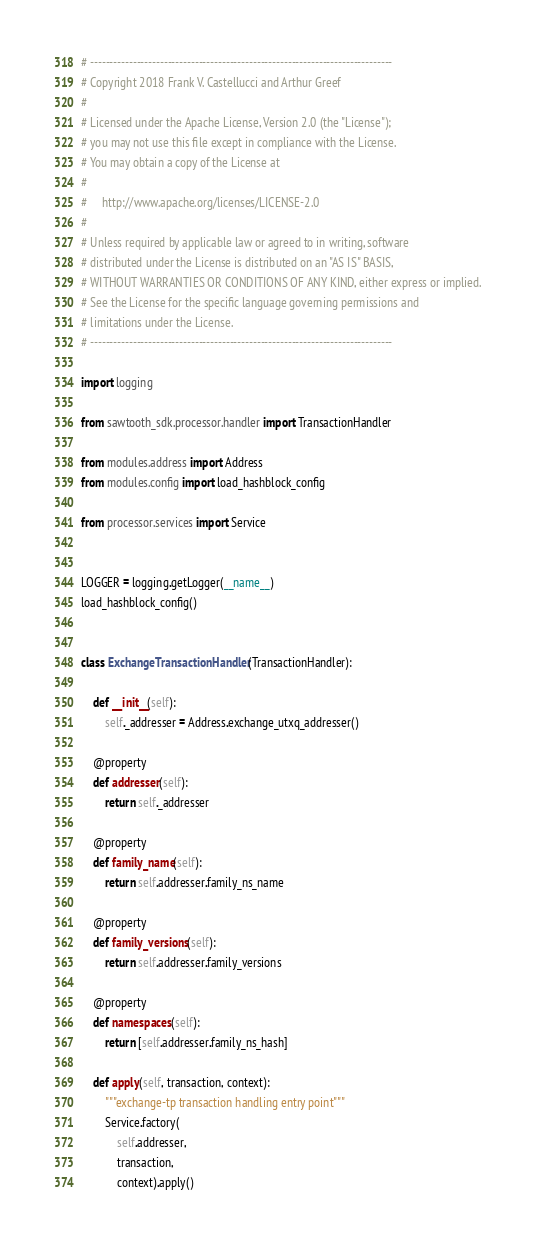<code> <loc_0><loc_0><loc_500><loc_500><_Python_># ------------------------------------------------------------------------------
# Copyright 2018 Frank V. Castellucci and Arthur Greef
#
# Licensed under the Apache License, Version 2.0 (the "License");
# you may not use this file except in compliance with the License.
# You may obtain a copy of the License at
#
#     http://www.apache.org/licenses/LICENSE-2.0
#
# Unless required by applicable law or agreed to in writing, software
# distributed under the License is distributed on an "AS IS" BASIS,
# WITHOUT WARRANTIES OR CONDITIONS OF ANY KIND, either express or implied.
# See the License for the specific language governing permissions and
# limitations under the License.
# ------------------------------------------------------------------------------

import logging

from sawtooth_sdk.processor.handler import TransactionHandler

from modules.address import Address
from modules.config import load_hashblock_config

from processor.services import Service


LOGGER = logging.getLogger(__name__)
load_hashblock_config()


class ExchangeTransactionHandler(TransactionHandler):

    def __init__(self):
        self._addresser = Address.exchange_utxq_addresser()

    @property
    def addresser(self):
        return self._addresser

    @property
    def family_name(self):
        return self.addresser.family_ns_name

    @property
    def family_versions(self):
        return self.addresser.family_versions

    @property
    def namespaces(self):
        return [self.addresser.family_ns_hash]

    def apply(self, transaction, context):
        """exchange-tp transaction handling entry point"""
        Service.factory(
            self.addresser,
            transaction,
            context).apply()
</code> 